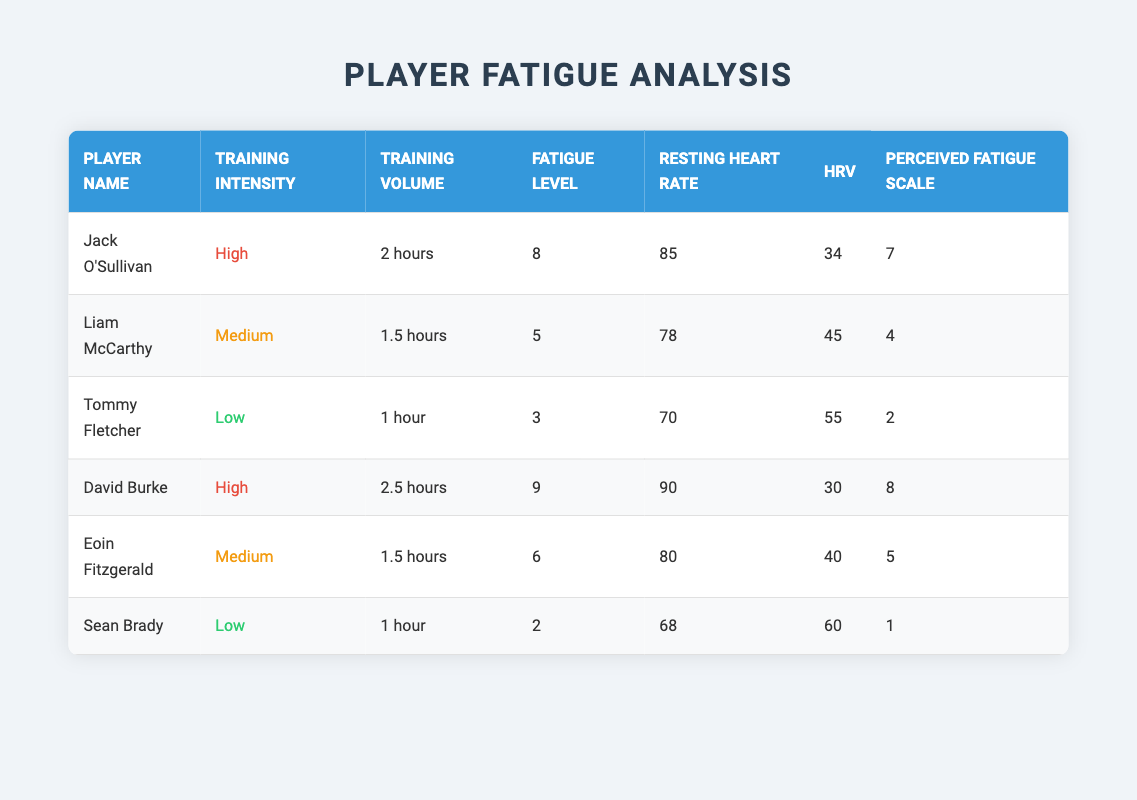What is the fatigue level of Jack O'Sullivan? The table shows a specific entry for Jack O'Sullivan, and his fatigue level is listed as 8.
Answer: 8 Which player has the highest resting heart rate? By looking at the resting heart rate column, David Burke has the highest resting heart rate at 90.
Answer: 90 What is the average fatigue level for players training at high intensity? Jack O'Sullivan's fatigue level is 8 and David Burke's is 9. To find the average, (8 + 9) / 2 = 8.5.
Answer: 8.5 Do any players training at low intensity have a fatigue level higher than 4? Sean Brady is the only player listed with low intensity training, and his fatigue level is 2, which is not higher than 4.
Answer: No What is the difference in fatigue levels between the player with the highest fatigue level and the player with the lowest? David Burke has the highest fatigue level at 9, while Sean Brady has the lowest at 2. The difference is 9 - 2 = 7.
Answer: 7 Which player under medium training intensity has the highest HRV? Liam McCarthy's HRV is 45 and Eoin Fitzgerald's HRV is 40. Since 45 is higher than 40, Liam McCarthy has the highest HRV under medium intensity.
Answer: Liam McCarthy What training volume is associated with the player who has the lowest perceived fatigue scale? Sean Brady has a perceived fatigue scale of 1, and his training volume is 1 hour.
Answer: 1 hour Is there a player whose perceived fatigue scale matches the fatigue level? Jack O'Sullivan has a fatigue level of 8 and a perceived fatigue scale of 7, while David Burke has a fatigue level of 9 and a perceived fatigue scale of 8, which matches.
Answer: Yes What is the total training volume of all players with high training intensity? Jack O'Sullivan trains for 2 hours and David Burke for 2.5 hours. The total is 2 + 2.5 = 4.5 hours.
Answer: 4.5 hours 